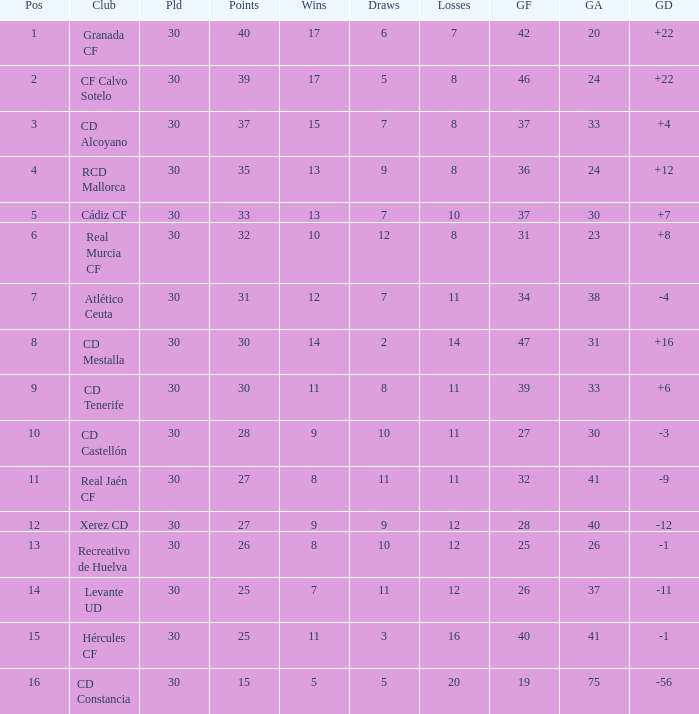Which Played has a Club of atlético ceuta, and less than 11 Losses? None. Could you parse the entire table as a dict? {'header': ['Pos', 'Club', 'Pld', 'Points', 'Wins', 'Draws', 'Losses', 'GF', 'GA', 'GD'], 'rows': [['1', 'Granada CF', '30', '40', '17', '6', '7', '42', '20', '+22'], ['2', 'CF Calvo Sotelo', '30', '39', '17', '5', '8', '46', '24', '+22'], ['3', 'CD Alcoyano', '30', '37', '15', '7', '8', '37', '33', '+4'], ['4', 'RCD Mallorca', '30', '35', '13', '9', '8', '36', '24', '+12'], ['5', 'Cádiz CF', '30', '33', '13', '7', '10', '37', '30', '+7'], ['6', 'Real Murcia CF', '30', '32', '10', '12', '8', '31', '23', '+8'], ['7', 'Atlético Ceuta', '30', '31', '12', '7', '11', '34', '38', '-4'], ['8', 'CD Mestalla', '30', '30', '14', '2', '14', '47', '31', '+16'], ['9', 'CD Tenerife', '30', '30', '11', '8', '11', '39', '33', '+6'], ['10', 'CD Castellón', '30', '28', '9', '10', '11', '27', '30', '-3'], ['11', 'Real Jaén CF', '30', '27', '8', '11', '11', '32', '41', '-9'], ['12', 'Xerez CD', '30', '27', '9', '9', '12', '28', '40', '-12'], ['13', 'Recreativo de Huelva', '30', '26', '8', '10', '12', '25', '26', '-1'], ['14', 'Levante UD', '30', '25', '7', '11', '12', '26', '37', '-11'], ['15', 'Hércules CF', '30', '25', '11', '3', '16', '40', '41', '-1'], ['16', 'CD Constancia', '30', '15', '5', '5', '20', '19', '75', '-56']]} 